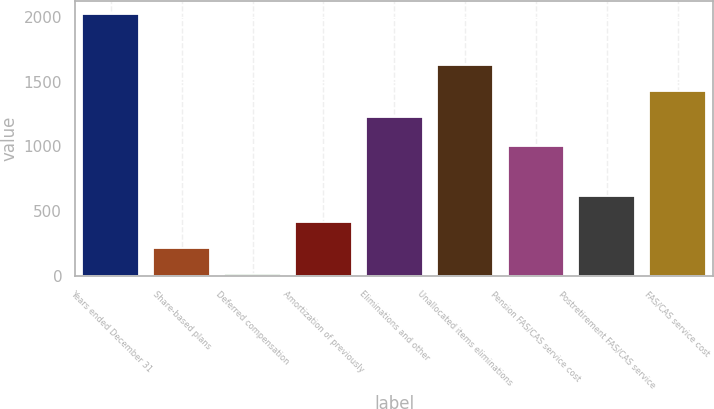Convert chart to OTSL. <chart><loc_0><loc_0><loc_500><loc_500><bar_chart><fcel>Years ended December 31<fcel>Share-based plans<fcel>Deferred compensation<fcel>Amortization of previously<fcel>Eliminations and other<fcel>Unallocated items eliminations<fcel>Pension FAS/CAS service cost<fcel>Postretirement FAS/CAS service<fcel>FAS/CAS service cost<nl><fcel>2018<fcel>218.9<fcel>19<fcel>418.8<fcel>1227<fcel>1626.8<fcel>1005<fcel>618.7<fcel>1426.9<nl></chart> 